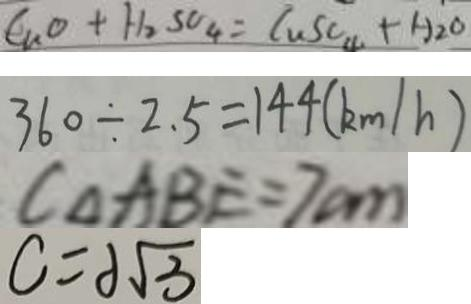Convert formula to latex. <formula><loc_0><loc_0><loc_500><loc_500>C _ { n } O + H _ { 2 } S O _ { 4 } = C u S O _ { 4 } + H _ { 2 } O 
 3 6 0 \div 2 . 5 = 1 4 4 ( k m / h ) 
 C _ { \Delta A B E } = 7 c m 
 C = 2 \sqrt { 3 }</formula> 